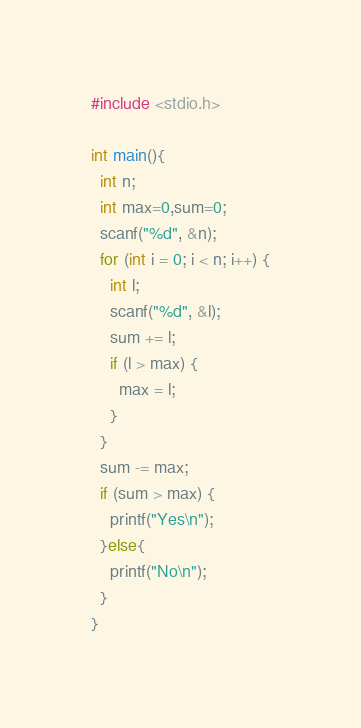<code> <loc_0><loc_0><loc_500><loc_500><_C_>#include <stdio.h>

int main(){
  int n;
  int max=0,sum=0;
  scanf("%d", &n);
  for (int i = 0; i < n; i++) {
    int l;
    scanf("%d", &l);
    sum += l;
    if (l > max) {
      max = l;
    }
  }
  sum -= max;
  if (sum > max) {
    printf("Yes\n");
  }else{
    printf("No\n");
  }
}
</code> 